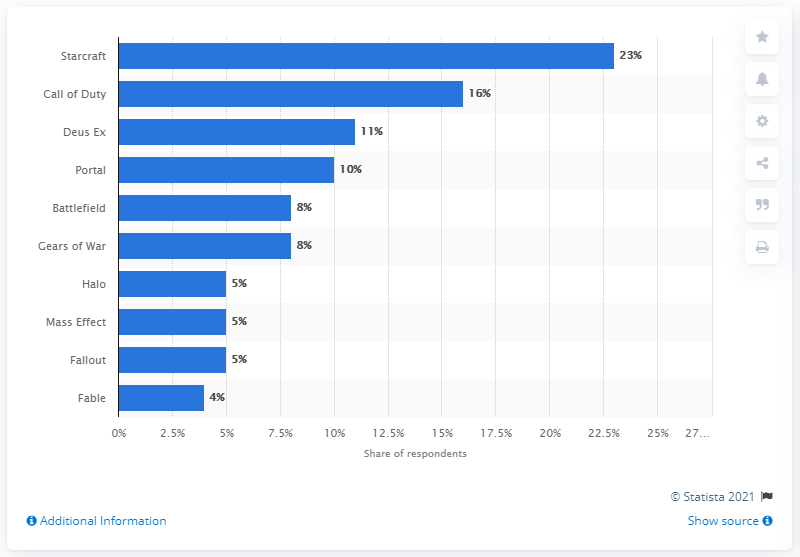Outline some significant characteristics in this image. In a survey conducted in 2011, 23% of respondents revealed that they had purchased a game from the Starcraft video game series. 